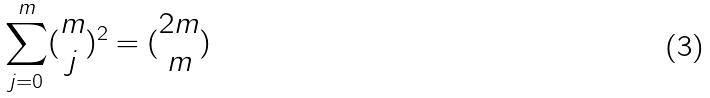Convert formula to latex. <formula><loc_0><loc_0><loc_500><loc_500>\sum _ { j = 0 } ^ { m } ( \begin{matrix} m \\ j \end{matrix} ) ^ { 2 } = ( \begin{matrix} 2 m \\ m \end{matrix} )</formula> 